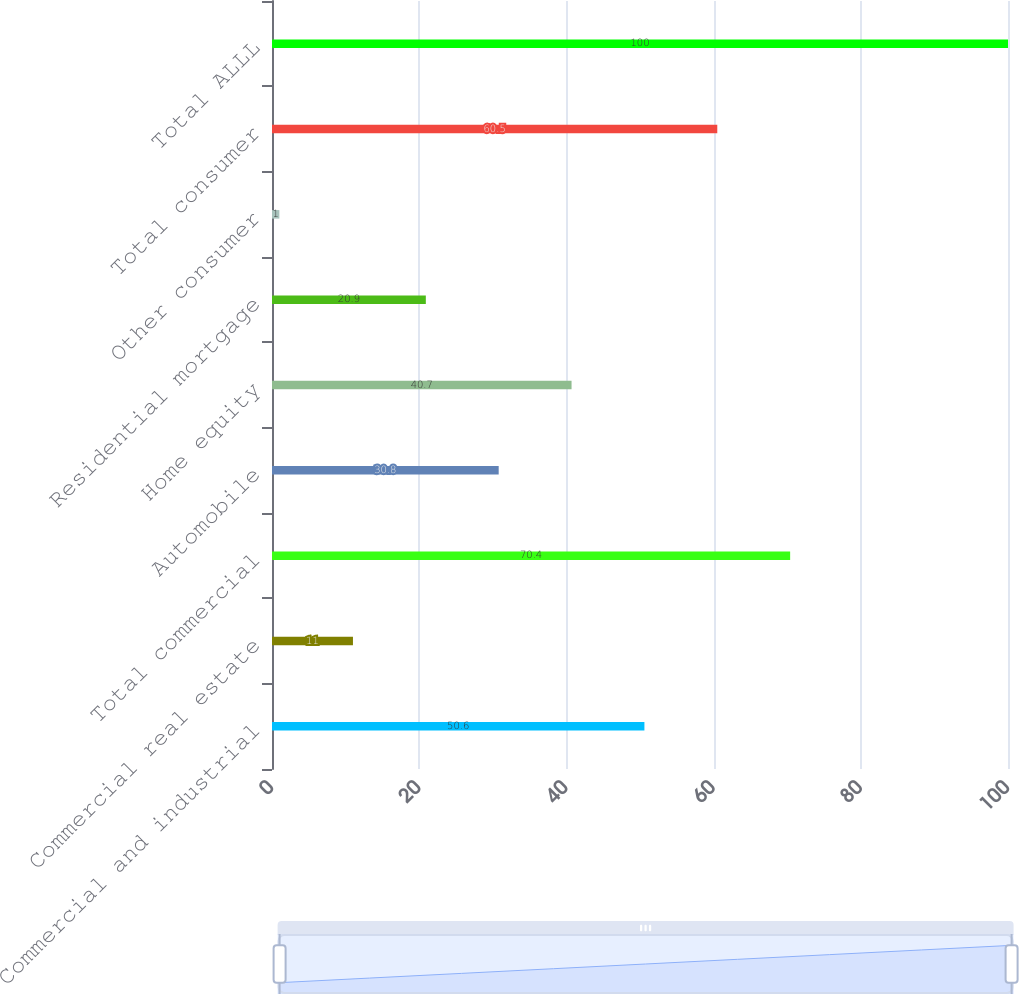Convert chart to OTSL. <chart><loc_0><loc_0><loc_500><loc_500><bar_chart><fcel>Commercial and industrial<fcel>Commercial real estate<fcel>Total commercial<fcel>Automobile<fcel>Home equity<fcel>Residential mortgage<fcel>Other consumer<fcel>Total consumer<fcel>Total ALLL<nl><fcel>50.6<fcel>11<fcel>70.4<fcel>30.8<fcel>40.7<fcel>20.9<fcel>1<fcel>60.5<fcel>100<nl></chart> 